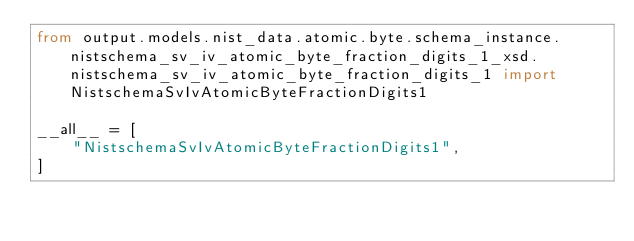Convert code to text. <code><loc_0><loc_0><loc_500><loc_500><_Python_>from output.models.nist_data.atomic.byte.schema_instance.nistschema_sv_iv_atomic_byte_fraction_digits_1_xsd.nistschema_sv_iv_atomic_byte_fraction_digits_1 import NistschemaSvIvAtomicByteFractionDigits1

__all__ = [
    "NistschemaSvIvAtomicByteFractionDigits1",
]
</code> 